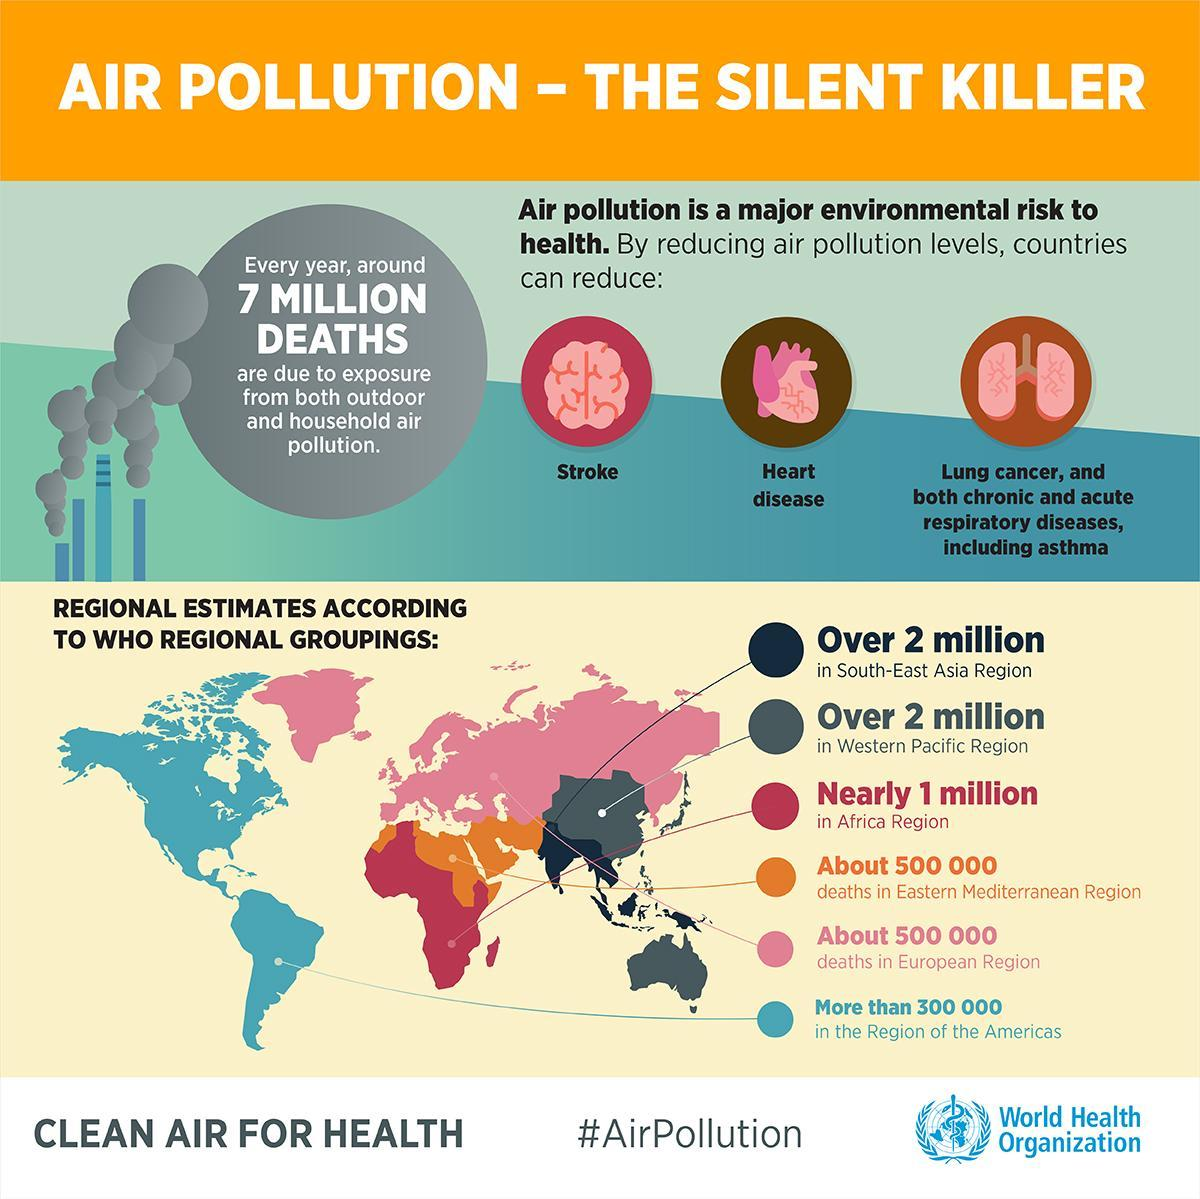Which region in the world has nearly 1 million deaths caused by air pollution according to WHO?
Answer the question with a short phrase. Africa Region What is the estimated number of deaths caused by air pollution in the European region according to WHO? 500 000 Which disease caused due to air pollution affects the brain? Stroke 